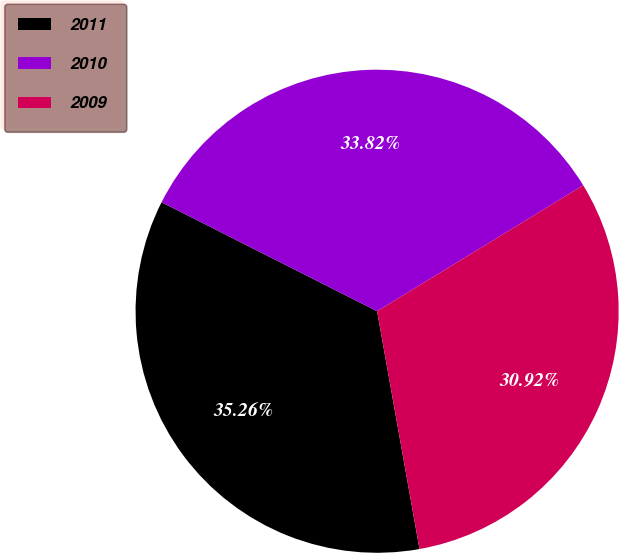<chart> <loc_0><loc_0><loc_500><loc_500><pie_chart><fcel>2011<fcel>2010<fcel>2009<nl><fcel>35.26%<fcel>33.82%<fcel>30.92%<nl></chart> 